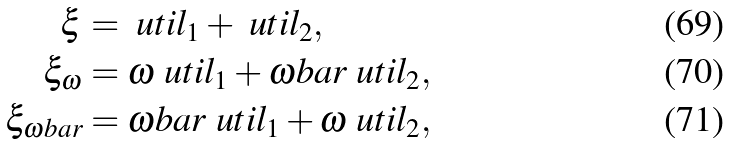Convert formula to latex. <formula><loc_0><loc_0><loc_500><loc_500>\xi & = \ u t i l _ { 1 } + \ u t i l _ { 2 } , \\ \xi _ { \omega } & = \omega \ u t i l _ { 1 } + \omega b a r \ u t i l _ { 2 } , \\ \xi _ { \omega b a r } & = \omega b a r \ u t i l _ { 1 } + \omega \ u t i l _ { 2 } ,</formula> 